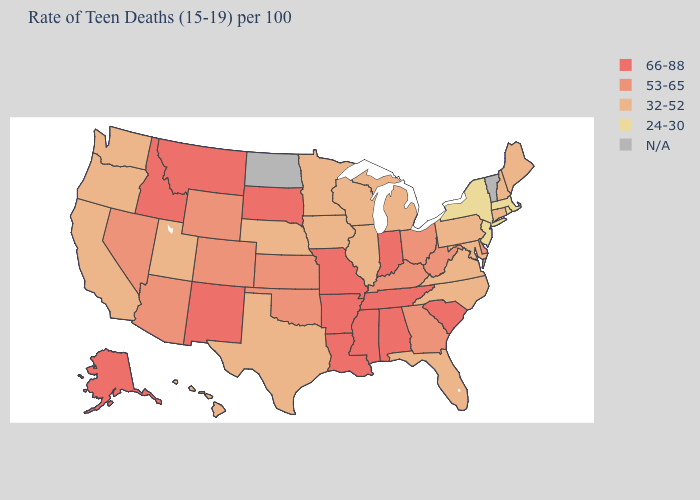Among the states that border Mississippi , which have the highest value?
Keep it brief. Alabama, Arkansas, Louisiana, Tennessee. What is the value of Rhode Island?
Short answer required. 24-30. Name the states that have a value in the range 32-52?
Quick response, please. California, Connecticut, Florida, Hawaii, Illinois, Iowa, Maine, Maryland, Michigan, Minnesota, Nebraska, New Hampshire, North Carolina, Oregon, Pennsylvania, Texas, Utah, Virginia, Washington, Wisconsin. Which states hav the highest value in the MidWest?
Keep it brief. Indiana, Missouri, South Dakota. Is the legend a continuous bar?
Write a very short answer. No. What is the value of Idaho?
Short answer required. 66-88. Does Florida have the highest value in the USA?
Quick response, please. No. Name the states that have a value in the range 66-88?
Concise answer only. Alabama, Alaska, Arkansas, Idaho, Indiana, Louisiana, Mississippi, Missouri, Montana, New Mexico, South Carolina, South Dakota, Tennessee. Name the states that have a value in the range 32-52?
Write a very short answer. California, Connecticut, Florida, Hawaii, Illinois, Iowa, Maine, Maryland, Michigan, Minnesota, Nebraska, New Hampshire, North Carolina, Oregon, Pennsylvania, Texas, Utah, Virginia, Washington, Wisconsin. Which states have the highest value in the USA?
Answer briefly. Alabama, Alaska, Arkansas, Idaho, Indiana, Louisiana, Mississippi, Missouri, Montana, New Mexico, South Carolina, South Dakota, Tennessee. What is the value of Washington?
Concise answer only. 32-52. Which states hav the highest value in the West?
Answer briefly. Alaska, Idaho, Montana, New Mexico. What is the value of Vermont?
Keep it brief. N/A. What is the highest value in the USA?
Give a very brief answer. 66-88. 